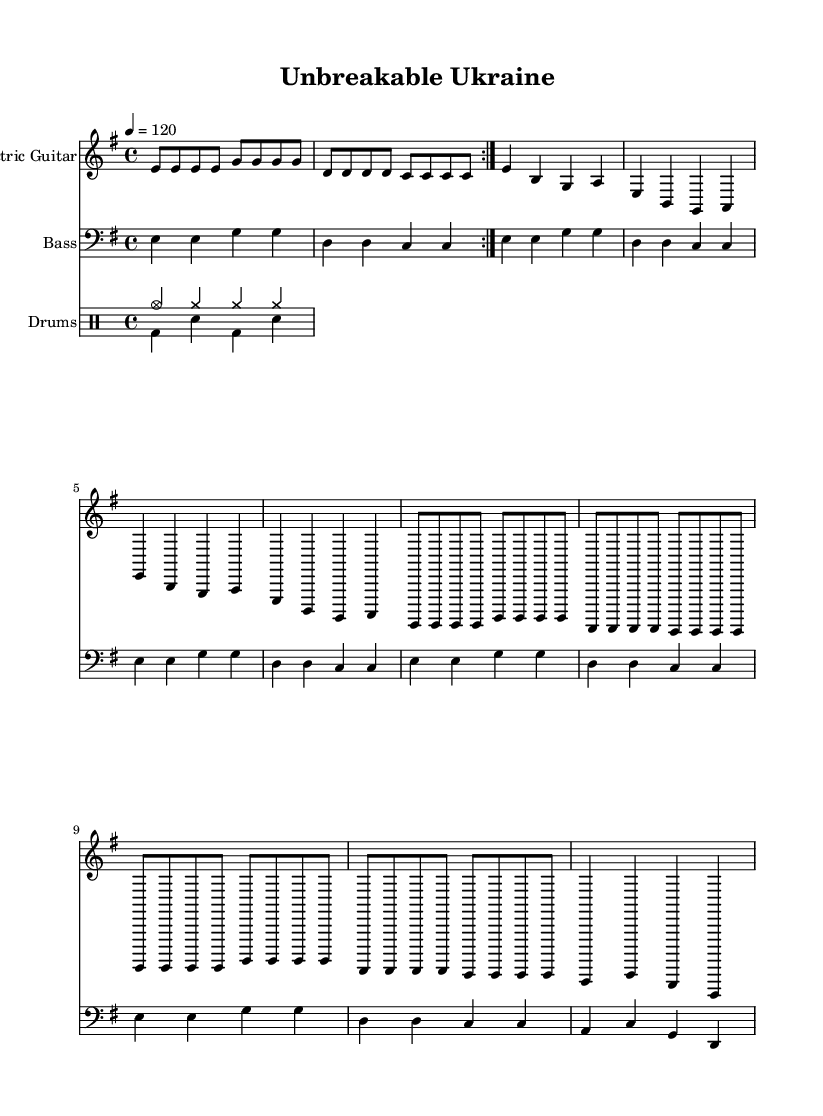What is the key signature of this music? The key signature is indicated by the position of the sharps or flats at the beginning of the staff. In this case, it shows that there are no sharps or flats, identifying the key as E minor.
Answer: E minor What is the time signature of this music? The time signature is shown as a fraction at the beginning of the music, which indicates the number of beats in a measure. Here, the 4 over 4 signifies that there are 4 beats per measure.
Answer: 4/4 What is the tempo marking of this music? The tempo marking indicates the speed of the music and is expressed as beats per minute. In this piece, it is notated as "4 = 120", meaning the quarter note is set to 120 beats per minute.
Answer: 120 How many measures are there in the verse? To determine the number of measures in the verse, we count the segments between the vertical lines indicating the end of each measure. There are 4 measures in the verse section here.
Answer: 4 What instruments are used in this piece? The instruments are specified at the beginning of each staff. This music includes Electric Guitar, Bass, and Drums.
Answer: Electric Guitar, Bass, Drums In what section does the bridge occur? The bridge in this piece is indicated by a change in musical content, usually following the verse or chorus. It is clearly marked as a distinct musical section in the score. Here, it comes after the chorus and has its own notes.
Answer: Bridge 